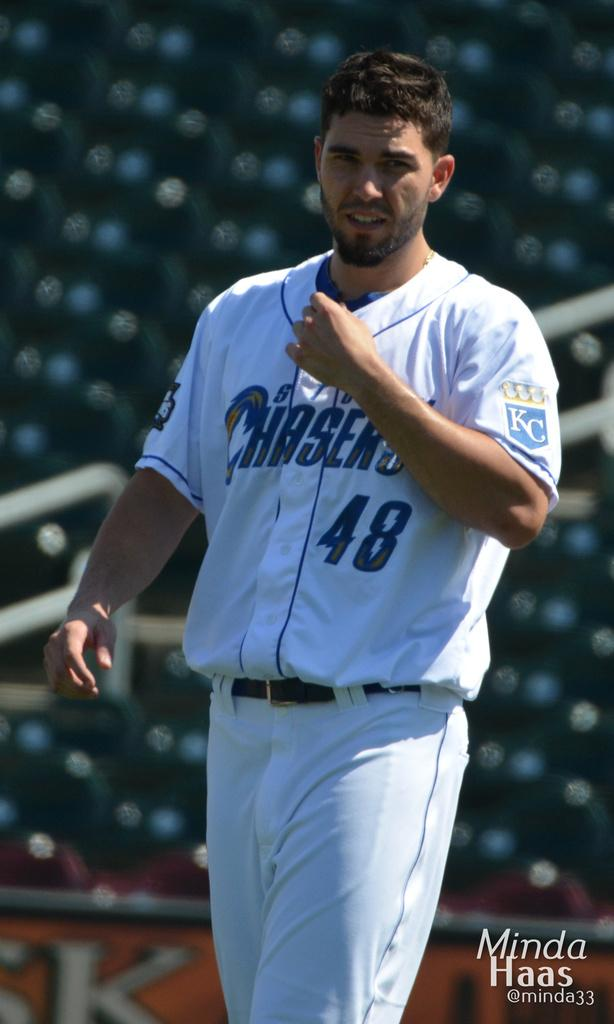<image>
Describe the image concisely. A Chasers player is standing in a stadium. 